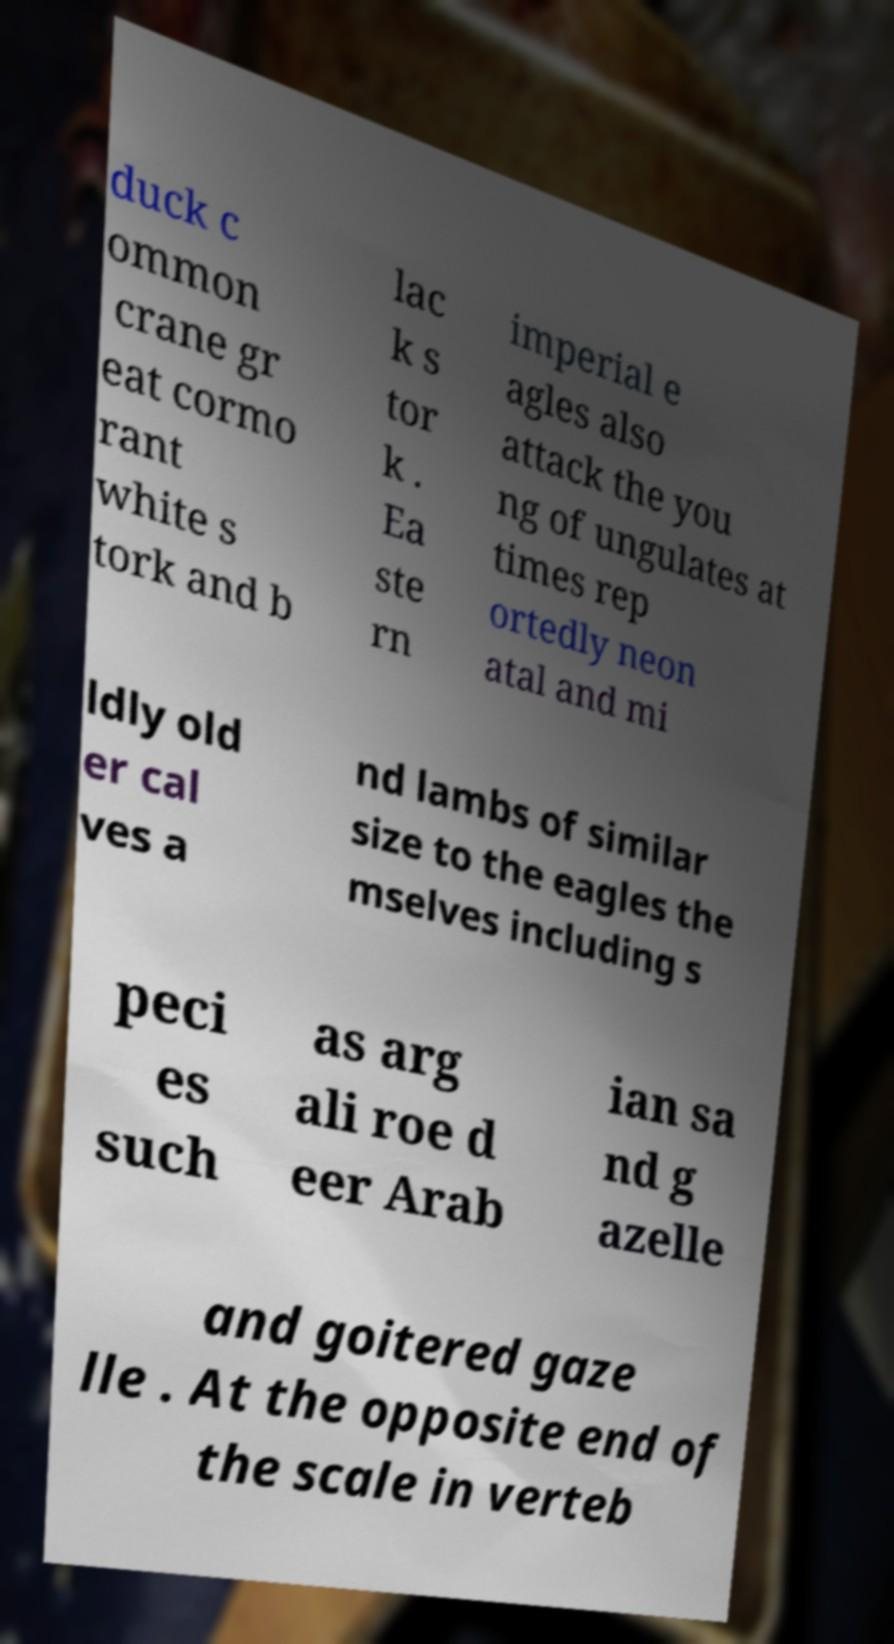Can you read and provide the text displayed in the image?This photo seems to have some interesting text. Can you extract and type it out for me? duck c ommon crane gr eat cormo rant white s tork and b lac k s tor k . Ea ste rn imperial e agles also attack the you ng of ungulates at times rep ortedly neon atal and mi ldly old er cal ves a nd lambs of similar size to the eagles the mselves including s peci es such as arg ali roe d eer Arab ian sa nd g azelle and goitered gaze lle . At the opposite end of the scale in verteb 